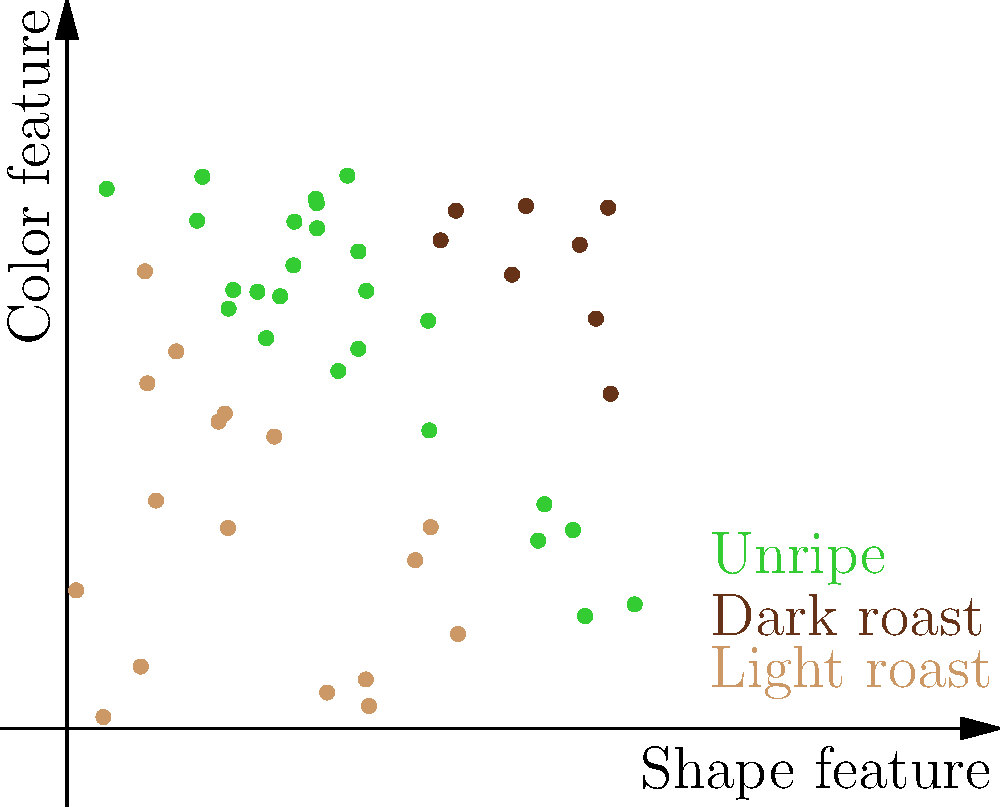Given the scatter plot of coffee bean features extracted from images, which machine learning algorithm would be most suitable for classifying the coffee beans into light roast, dark roast, and unripe categories? To determine the most suitable machine learning algorithm for this classification task, let's analyze the data and problem characteristics:

1. Data representation: The scatter plot shows two features (shape and color) extracted from coffee bean images.

2. Number of classes: There are three distinct classes - light roast, dark roast, and unripe beans.

3. Data distribution: The classes appear to be linearly separable, with clear boundaries between them.

4. Dataset size: The sample size seems relatively small, with about 50 data points visible.

5. Dimensionality: The problem has low dimensionality, with only two features.

Given these characteristics, we can consider the following algorithms:

a) Support Vector Machines (SVM): Effective for linearly separable data and works well with small datasets.

b) Logistic Regression: Can handle multi-class problems and works well with linearly separable data.

c) k-Nearest Neighbors (k-NN): Simple and effective for low-dimensional data but may not generalize well.

d) Decision Trees: Can handle non-linear boundaries but might overfit with small datasets.

e) Neural Networks: Powerful but may be overkill for this simple, linearly separable problem.

Considering the linear separability, low dimensionality, and small dataset size, the most suitable algorithm would be Support Vector Machines (SVM). SVM can effectively find the optimal hyperplanes to separate the three classes, works well with small datasets, and is less prone to overfitting compared to more complex algorithms.
Answer: Support Vector Machines (SVM) 